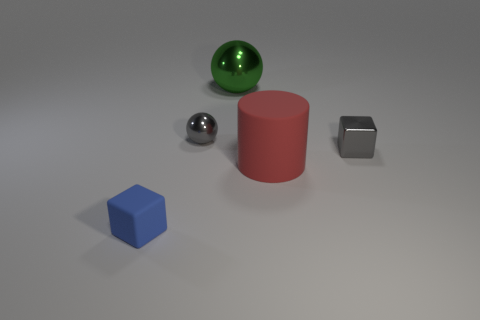What shape is the tiny blue object that is the same material as the cylinder?
Provide a short and direct response. Cube. Do the red thing and the small cube that is on the right side of the green sphere have the same material?
Keep it short and to the point. No. Do the small thing that is right of the green metal ball and the big shiny thing have the same shape?
Offer a terse response. No. There is a tiny gray object that is the same shape as the green object; what is it made of?
Keep it short and to the point. Metal. There is a green shiny object; is it the same shape as the tiny gray metallic object that is on the right side of the large red matte thing?
Ensure brevity in your answer.  No. The tiny object that is behind the red rubber object and on the left side of the red cylinder is what color?
Your answer should be very brief. Gray. Is there a tiny blue metal cube?
Ensure brevity in your answer.  No. Are there an equal number of tiny gray things that are behind the big green object and big green objects?
Keep it short and to the point. No. How many other things are the same shape as the red matte object?
Keep it short and to the point. 0. What is the shape of the green shiny thing?
Offer a very short reply. Sphere. 